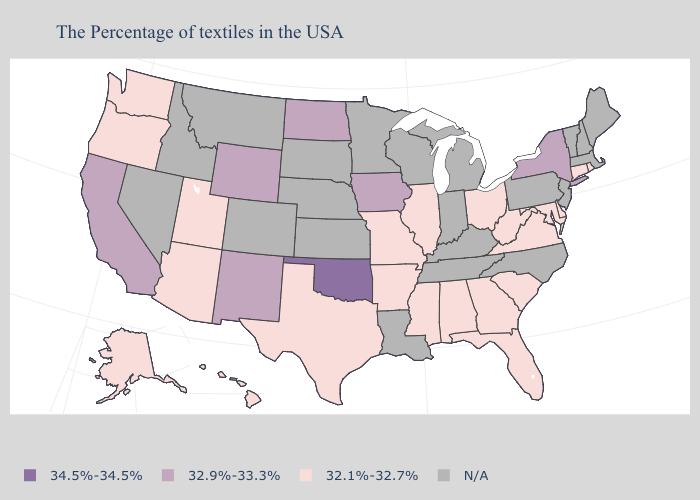Does Oklahoma have the highest value in the USA?
Short answer required. Yes. What is the highest value in the USA?
Write a very short answer. 34.5%-34.5%. Name the states that have a value in the range 32.9%-33.3%?
Answer briefly. New York, Iowa, North Dakota, Wyoming, New Mexico, California. Name the states that have a value in the range 32.9%-33.3%?
Concise answer only. New York, Iowa, North Dakota, Wyoming, New Mexico, California. Name the states that have a value in the range 32.1%-32.7%?
Keep it brief. Rhode Island, Connecticut, Delaware, Maryland, Virginia, South Carolina, West Virginia, Ohio, Florida, Georgia, Alabama, Illinois, Mississippi, Missouri, Arkansas, Texas, Utah, Arizona, Washington, Oregon, Alaska, Hawaii. What is the value of New Hampshire?
Answer briefly. N/A. Which states hav the highest value in the MidWest?
Quick response, please. Iowa, North Dakota. Does Arkansas have the highest value in the South?
Quick response, please. No. Name the states that have a value in the range 32.9%-33.3%?
Quick response, please. New York, Iowa, North Dakota, Wyoming, New Mexico, California. Does Illinois have the lowest value in the USA?
Give a very brief answer. Yes. Does New York have the highest value in the Northeast?
Answer briefly. Yes. Does Iowa have the lowest value in the MidWest?
Keep it brief. No. 